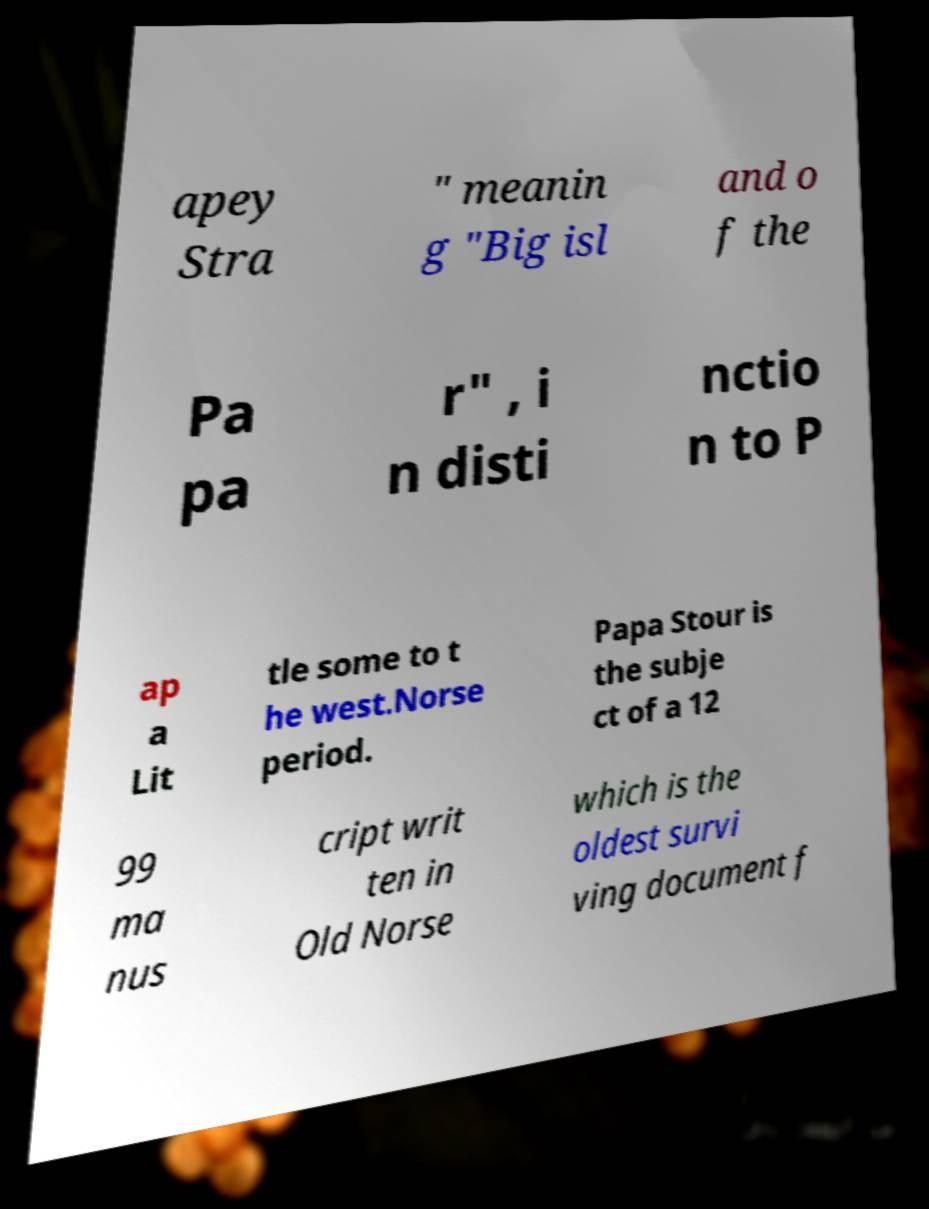Please read and relay the text visible in this image. What does it say? apey Stra " meanin g "Big isl and o f the Pa pa r" , i n disti nctio n to P ap a Lit tle some to t he west.Norse period. Papa Stour is the subje ct of a 12 99 ma nus cript writ ten in Old Norse which is the oldest survi ving document f 